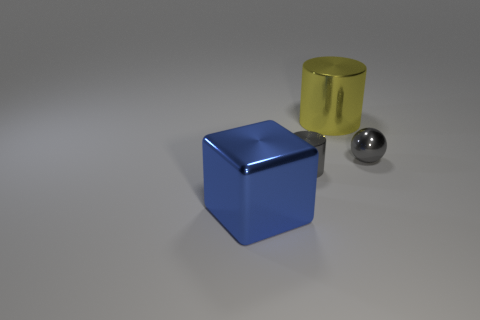What is the color of the other metallic object that is the same shape as the large yellow shiny thing?
Provide a short and direct response. Gray. Is the yellow metallic object the same shape as the large blue thing?
Ensure brevity in your answer.  No. There is another object that is the same shape as the yellow object; what size is it?
Ensure brevity in your answer.  Small. How many other large objects have the same material as the large yellow object?
Offer a very short reply. 1. What number of objects are either big yellow things or metallic balls?
Your response must be concise. 2. Is there a large blue cube that is behind the large metal object on the right side of the blue metallic cube?
Your answer should be compact. No. Is the number of big blue cubes on the left side of the small gray cylinder greater than the number of yellow objects that are in front of the large yellow thing?
Keep it short and to the point. Yes. There is a object that is the same color as the small metal cylinder; what is its material?
Give a very brief answer. Metal. How many tiny shiny cylinders are the same color as the shiny ball?
Your response must be concise. 1. There is a small shiny thing that is on the left side of the gray ball; is it the same color as the tiny shiny ball in front of the big cylinder?
Ensure brevity in your answer.  Yes. 